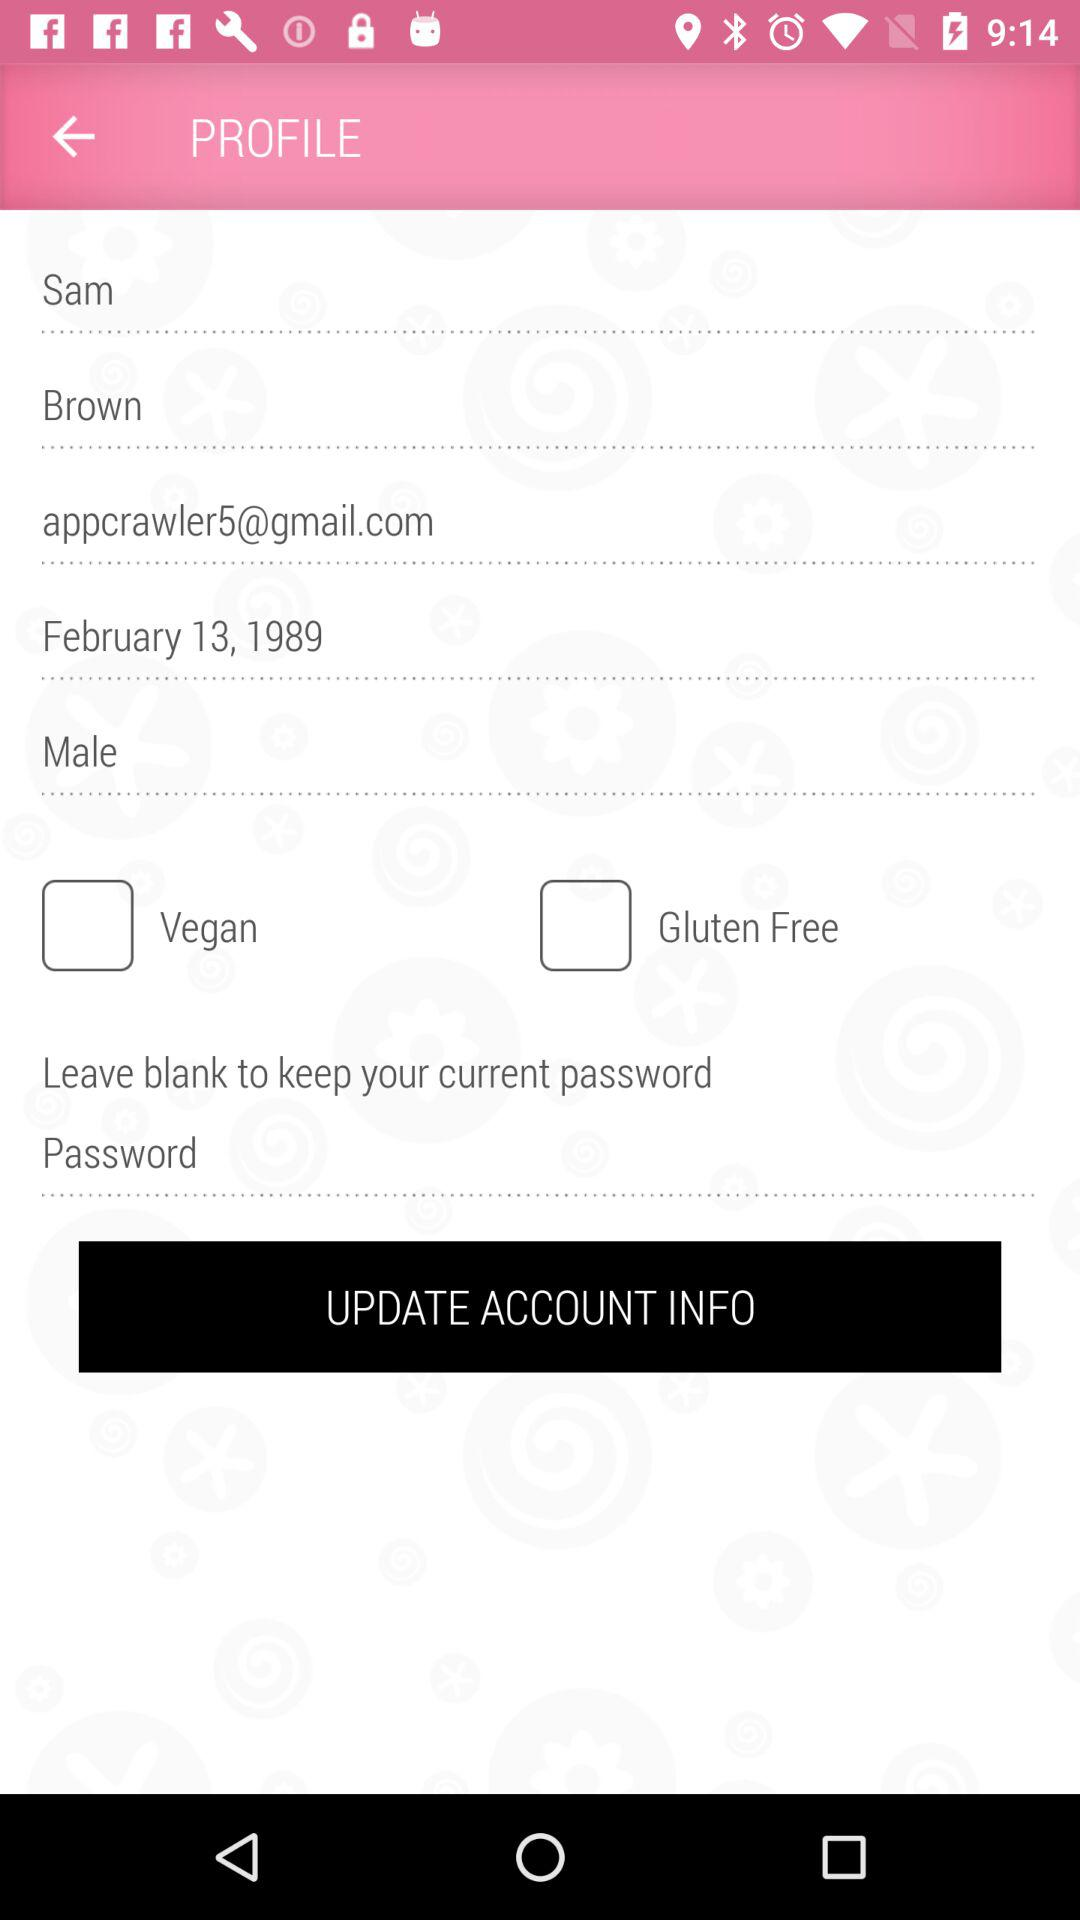What is the email address? The email address is appcrawler5@gmail.com. 